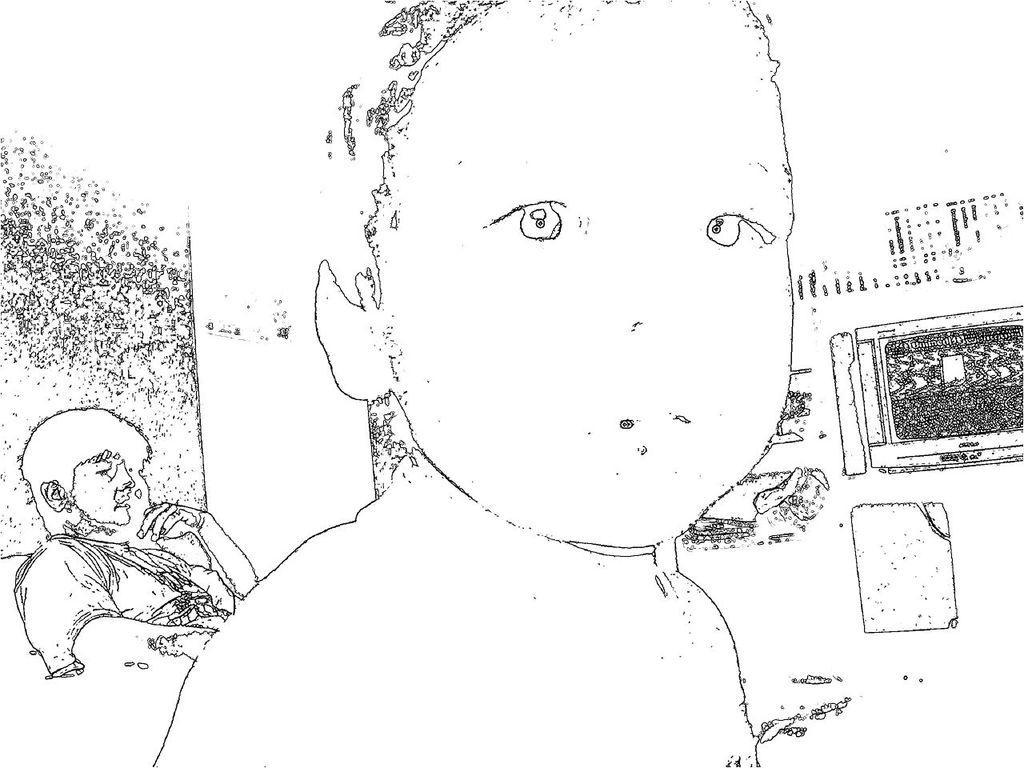How would you summarize this image in a sentence or two? In this picture I can see the digital of 2 persons and other things and I see the color of the sketch is black and white. 